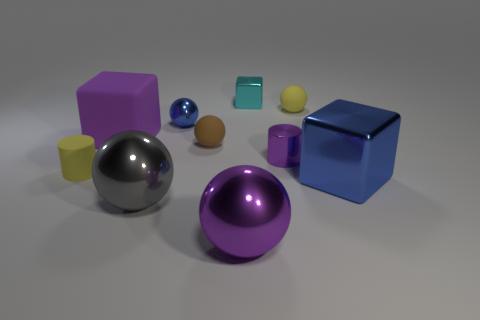Subtract 1 balls. How many balls are left? 4 Subtract all yellow blocks. Subtract all yellow cylinders. How many blocks are left? 3 Subtract all cylinders. How many objects are left? 8 Subtract 0 yellow cubes. How many objects are left? 10 Subtract all tiny cylinders. Subtract all purple things. How many objects are left? 5 Add 8 purple metallic things. How many purple metallic things are left? 10 Add 2 large metallic balls. How many large metallic balls exist? 4 